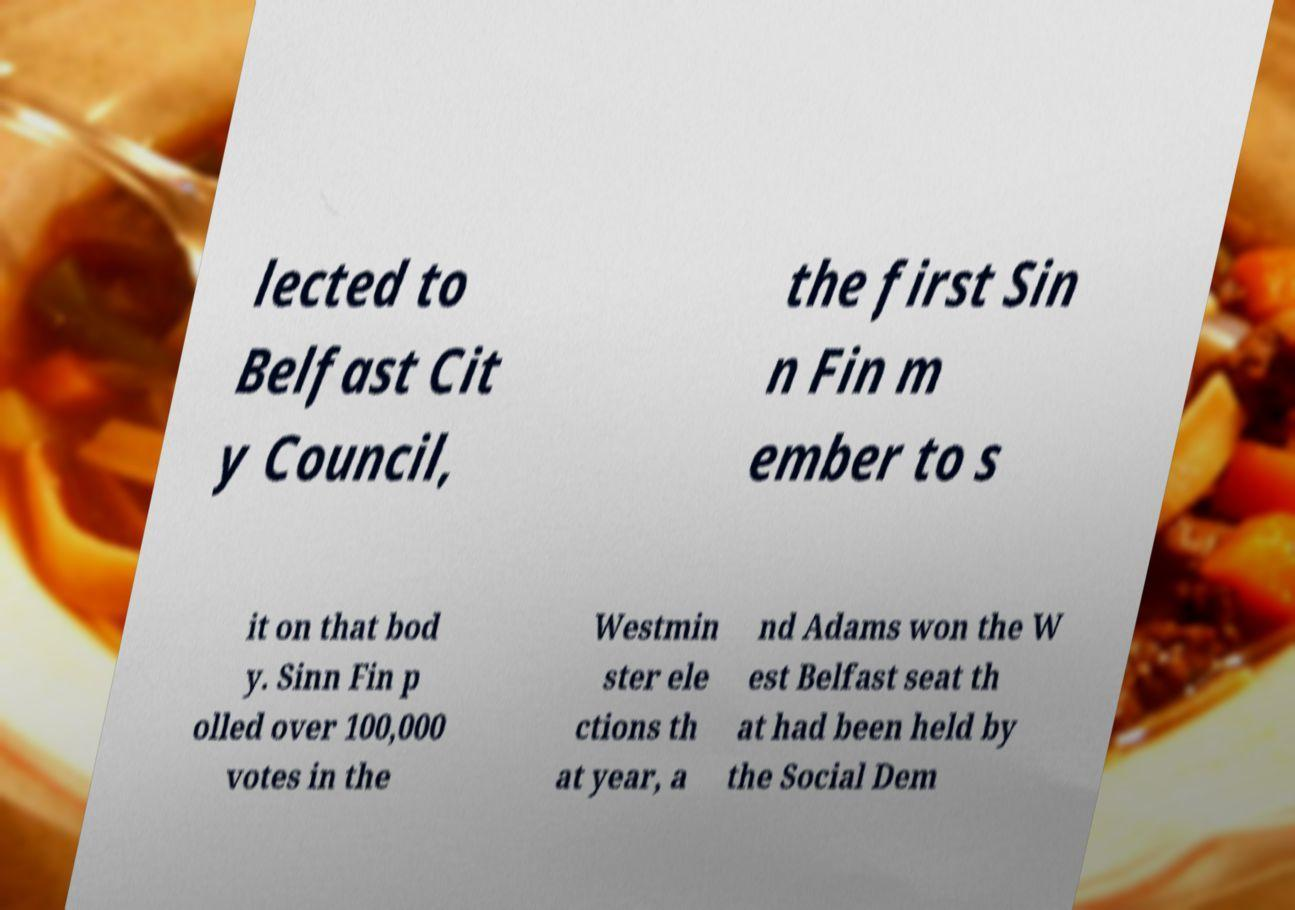Could you assist in decoding the text presented in this image and type it out clearly? lected to Belfast Cit y Council, the first Sin n Fin m ember to s it on that bod y. Sinn Fin p olled over 100,000 votes in the Westmin ster ele ctions th at year, a nd Adams won the W est Belfast seat th at had been held by the Social Dem 